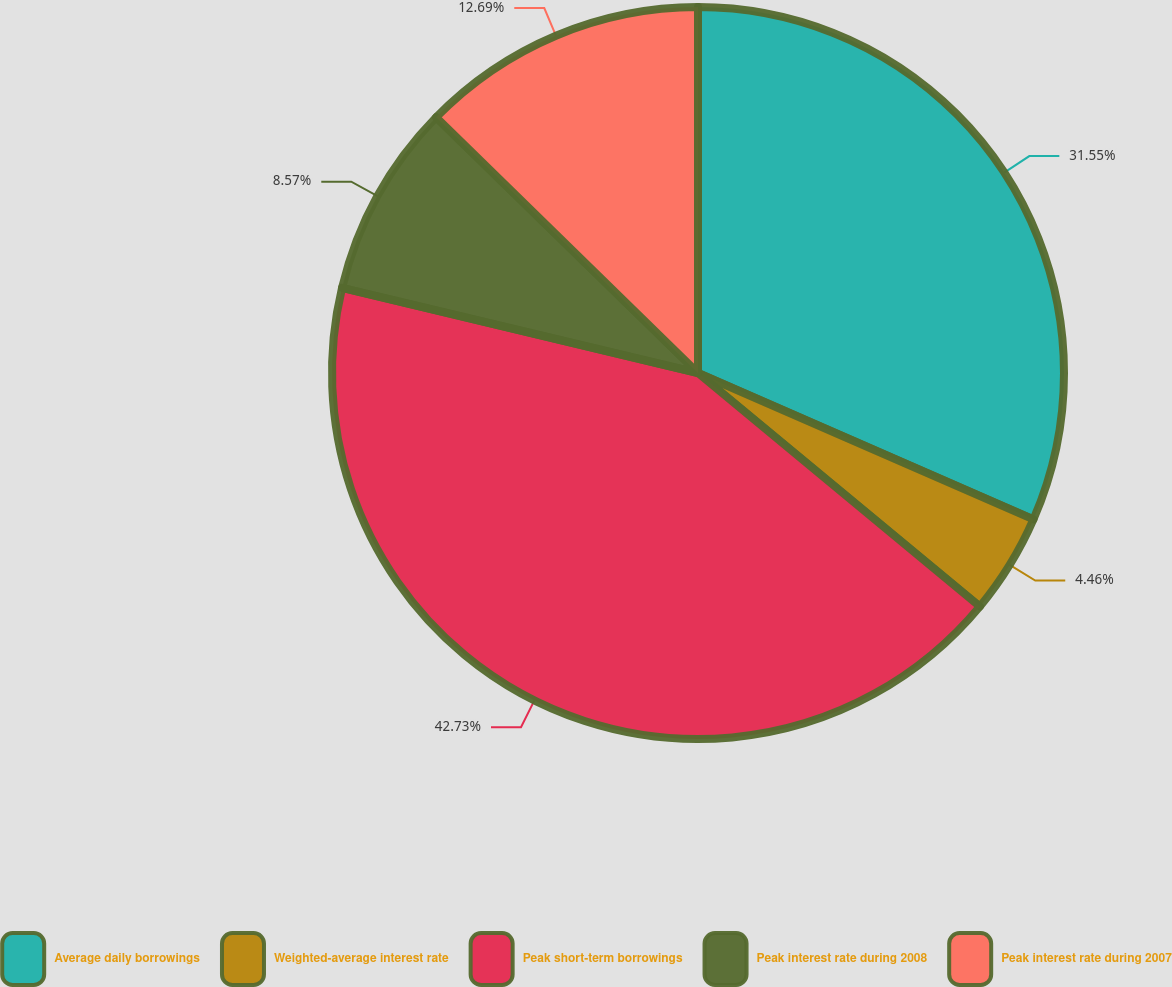Convert chart to OTSL. <chart><loc_0><loc_0><loc_500><loc_500><pie_chart><fcel>Average daily borrowings<fcel>Weighted-average interest rate<fcel>Peak short-term borrowings<fcel>Peak interest rate during 2008<fcel>Peak interest rate during 2007<nl><fcel>31.55%<fcel>4.46%<fcel>42.73%<fcel>8.57%<fcel>12.69%<nl></chart> 